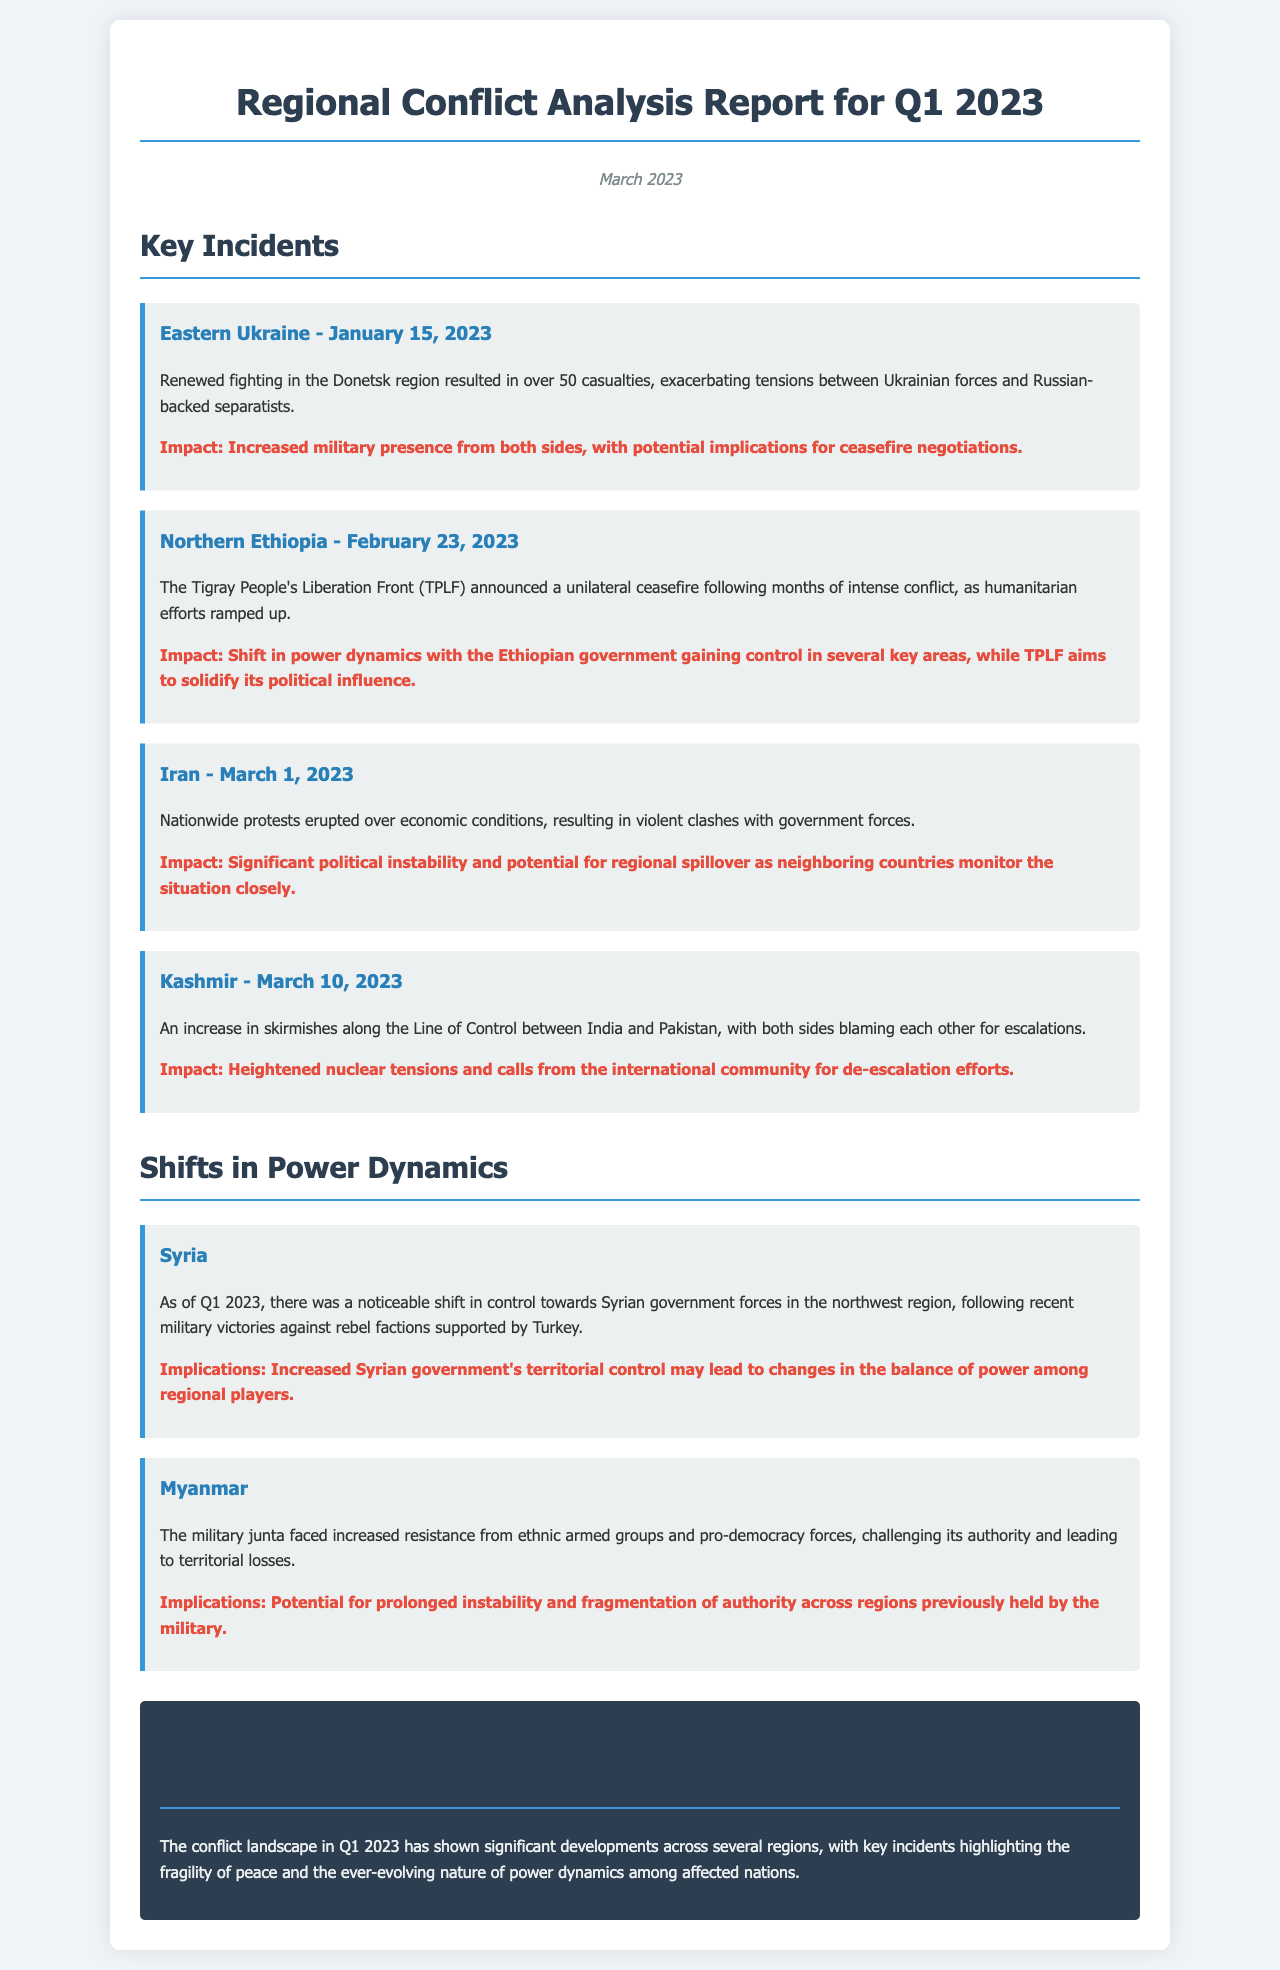what was the date of the incident in Eastern Ukraine? The date when renewed fighting occurred in Eastern Ukraine was specified in the document.
Answer: January 15, 2023 how many casualties were reported in Eastern Ukraine? The document states the number of casualties resulting from the fighting in Eastern Ukraine.
Answer: over 50 what region experienced a unilateral ceasefire announced by TPLF? The document mentions the region where the TPLF announced a ceasefire.
Answer: Northern Ethiopia which country's nationwide protests led to clashes with government forces in March 2023? The document identifies the country where protests erupted due to economic conditions.
Answer: Iran what were the implications of the Syrian government's territorial control? The document provides implications regarding the increased control of the Syrian government.
Answer: Changes in the balance of power how did the military junta in Myanmar respond to increased resistance? The document describes the military junta's challenges in Myanmar that affected its authority.
Answer: Territorial losses what is the overall conclusion regarding the conflict landscape in Q1 2023? The conclusion summarizes the developments observed in the conflict landscape during this quarter.
Answer: Significant developments across several regions what is emphasized about the power dynamics in the reports? The report highlights aspects of power dynamics referencing changes and implications across affected nations.
Answer: Fragility of peace 